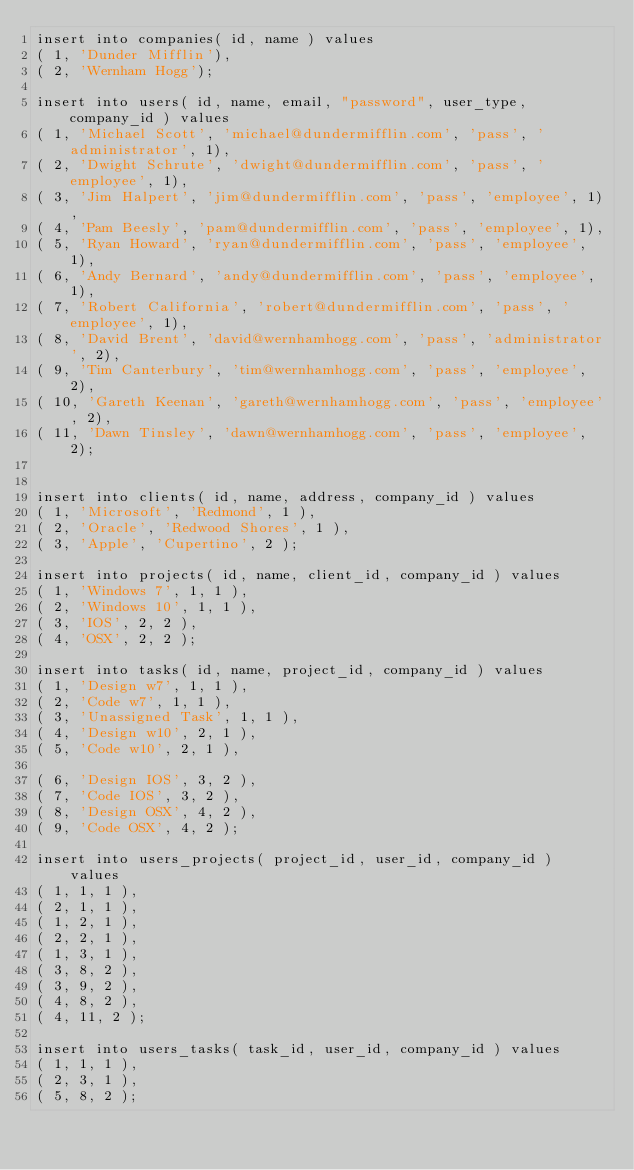<code> <loc_0><loc_0><loc_500><loc_500><_SQL_>insert into companies( id, name ) values
( 1, 'Dunder Mifflin'),
( 2, 'Wernham Hogg');

insert into users( id, name, email, "password", user_type, company_id ) values
( 1, 'Michael Scott', 'michael@dundermifflin.com', 'pass', 'administrator', 1),
( 2, 'Dwight Schrute', 'dwight@dundermifflin.com', 'pass', 'employee', 1),
( 3, 'Jim Halpert', 'jim@dundermifflin.com', 'pass', 'employee', 1),
( 4, 'Pam Beesly', 'pam@dundermifflin.com', 'pass', 'employee', 1),
( 5, 'Ryan Howard', 'ryan@dundermifflin.com', 'pass', 'employee', 1),
( 6, 'Andy Bernard', 'andy@dundermifflin.com', 'pass', 'employee', 1),
( 7, 'Robert California', 'robert@dundermifflin.com', 'pass', 'employee', 1),
( 8, 'David Brent', 'david@wernhamhogg.com', 'pass', 'administrator', 2),
( 9, 'Tim Canterbury', 'tim@wernhamhogg.com', 'pass', 'employee', 2),
( 10, 'Gareth Keenan', 'gareth@wernhamhogg.com', 'pass', 'employee', 2),
( 11, 'Dawn Tinsley', 'dawn@wernhamhogg.com', 'pass', 'employee', 2);


insert into clients( id, name, address, company_id ) values
( 1, 'Microsoft', 'Redmond', 1 ),
( 2, 'Oracle', 'Redwood Shores', 1 ), 
( 3, 'Apple', 'Cupertino', 2 );

insert into projects( id, name, client_id, company_id ) values
( 1, 'Windows 7', 1, 1 ),
( 2, 'Windows 10', 1, 1 ),
( 3, 'IOS', 2, 2 ),
( 4, 'OSX', 2, 2 );

insert into tasks( id, name, project_id, company_id ) values
( 1, 'Design w7', 1, 1 ),
( 2, 'Code w7', 1, 1 ),
( 3, 'Unassigned Task', 1, 1 ),
( 4, 'Design w10', 2, 1 ),
( 5, 'Code w10', 2, 1 ),

( 6, 'Design IOS', 3, 2 ),
( 7, 'Code IOS', 3, 2 ),
( 8, 'Design OSX', 4, 2 ),
( 9, 'Code OSX', 4, 2 );

insert into users_projects( project_id, user_id, company_id ) values
( 1, 1, 1 ),
( 2, 1, 1 ),
( 1, 2, 1 ),
( 2, 2, 1 ),
( 1, 3, 1 ),
( 3, 8, 2 ),
( 3, 9, 2 ),
( 4, 8, 2 ),
( 4, 11, 2 );

insert into users_tasks( task_id, user_id, company_id ) values
( 1, 1, 1 ),
( 2, 3, 1 ),
( 5, 8, 2 );</code> 